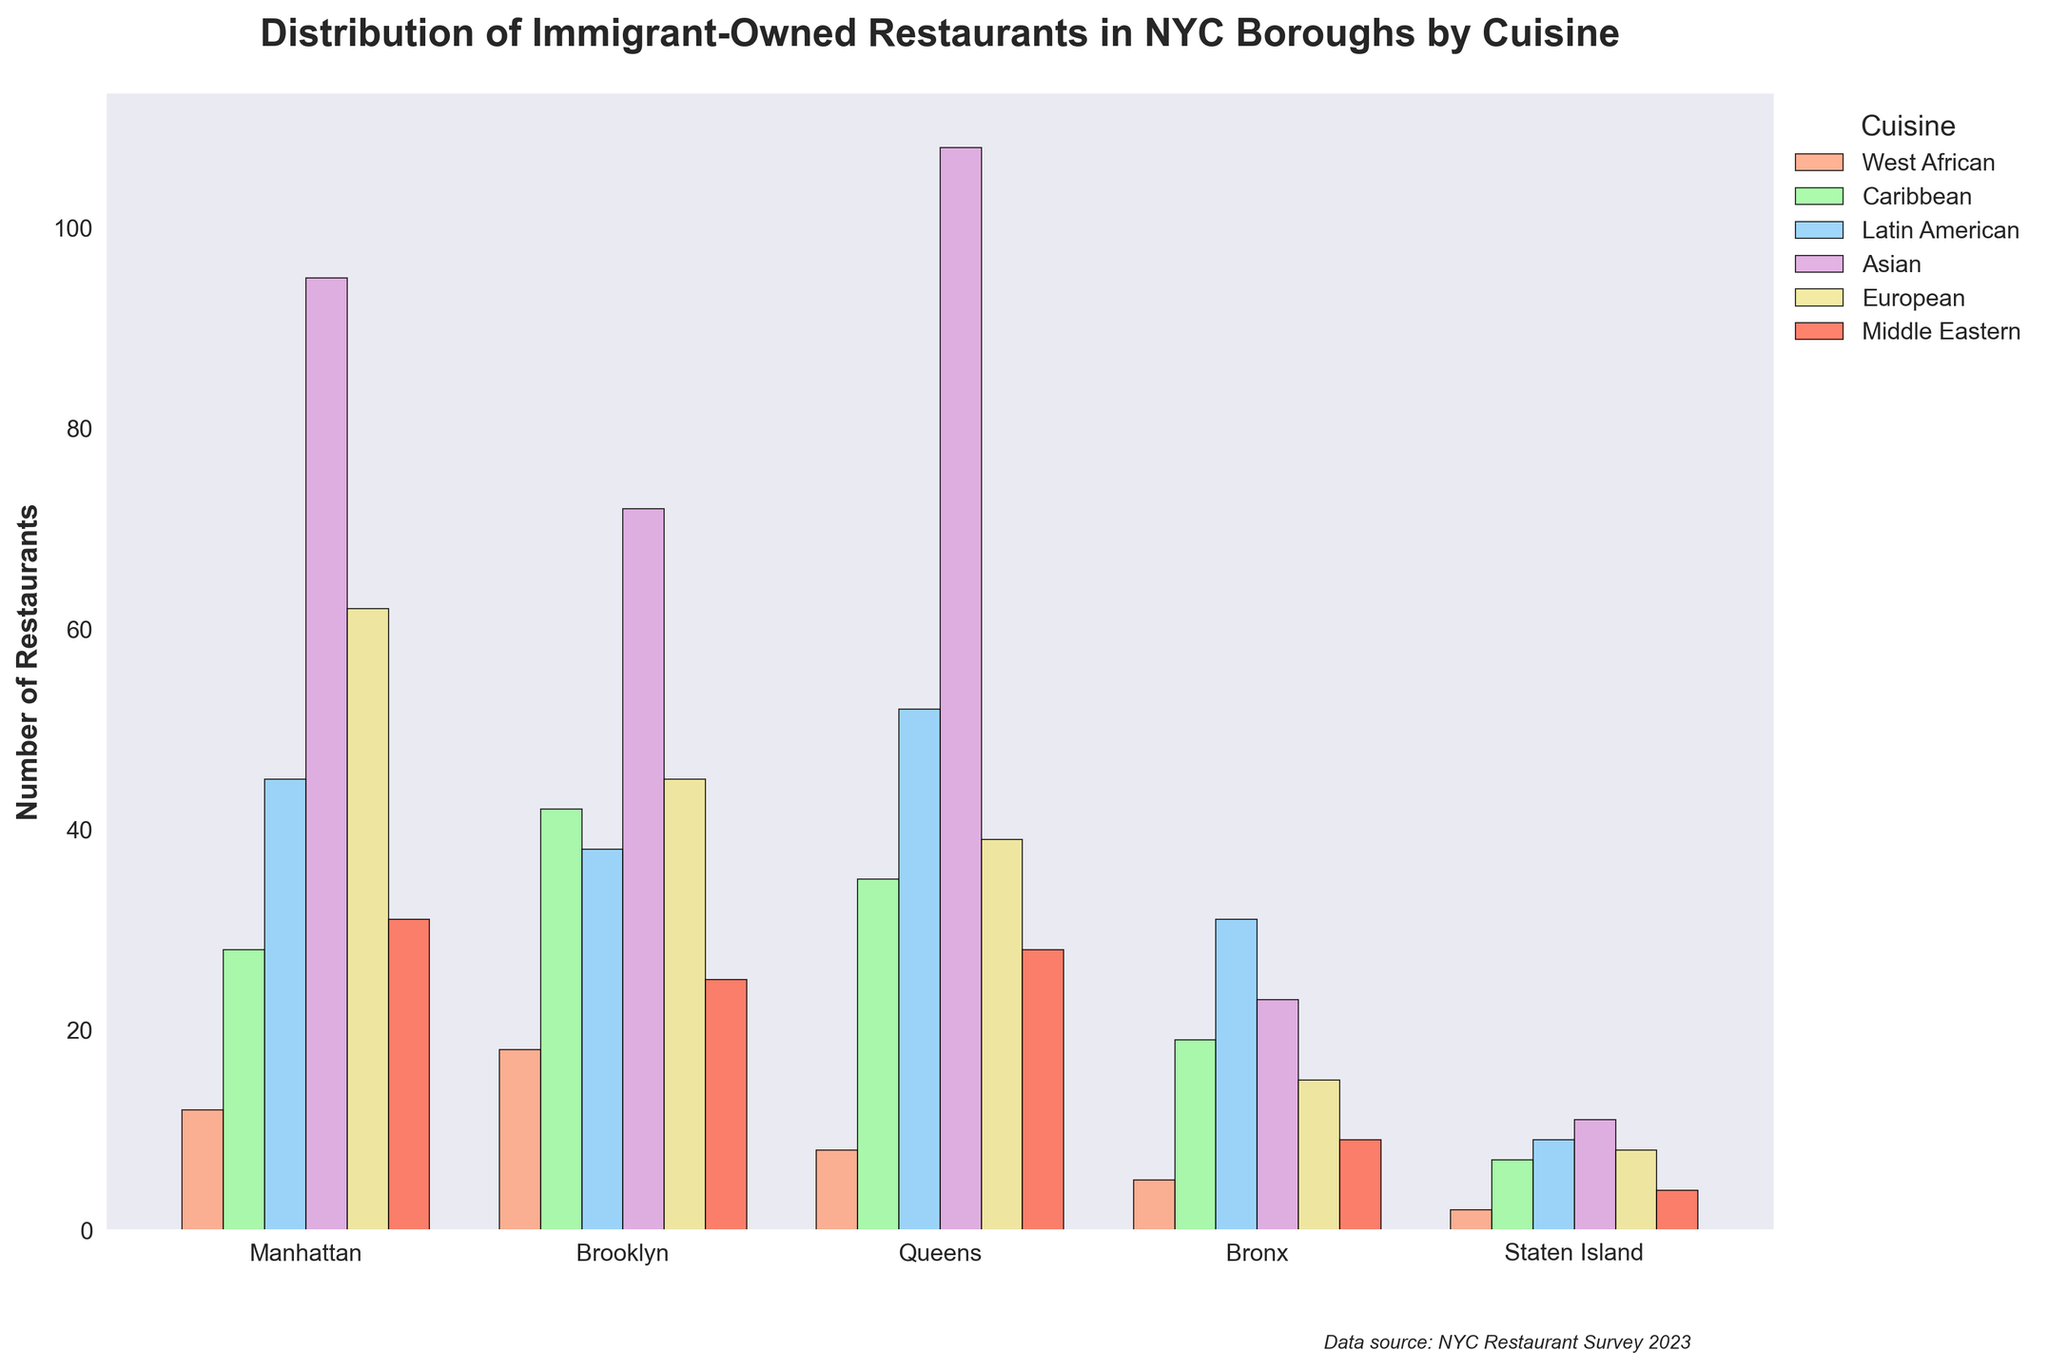What borough has the highest number of immigrant-owned Asian restaurants? The figure shows the number of immigrant-owned Asian restaurants in each borough. Looking at the Asian category, Queens has the highest number with 108 restaurants.
Answer: Queens Which cuisine is the most represented in the Bronx? By comparing the heights of the bars for each cuisine in the Bronx, Latin American stands out with the highest value of 31.
Answer: Latin American How many more Caribbean restaurants are there in Brooklyn compared to Staten Island? The number of Caribbean restaurants in Brooklyn is 42, while in Staten Island it is 7. Subtracting 7 from 42 gives us 35 more Caribbean restaurants in Brooklyn.
Answer: 35 Which borough has the smallest number of immigrant-owned European restaurants? The figure shows the number of European restaurants in each borough. Staten Island has the smallest number with 8 restaurants.
Answer: Staten Island If we sum up the number of Middle Eastern restaurants in Manhattan and Brooklyn, what do we get? Manhattan has 31 Middle Eastern restaurants, and Brooklyn has 25. Adding these together gives us 31 + 25 = 56.
Answer: 56 What is the average number of Latin American restaurants in all boroughs? Adding the number of Latin American restaurants across all boroughs: 45 (Manhattan) + 38 (Brooklyn) + 52 (Queens) + 31 (Bronx) + 9 (Staten Island) = 175. Dividing by the number of boroughs (5) gives us an average of 35.
Answer: 35 In which borough are immigrant-owned West African restaurants least represented? The figure shows the number of West African restaurants in each borough. Staten Island has the least, with only 2.
Answer: Staten Island Compare the number of West African restaurants in Manhattan to those in Brooklyn. Which borough has more? Manhattan has 12 West African restaurants, while Brooklyn has 18. Brooklyn has more West African restaurants.
Answer: Brooklyn How many more European restaurants are there in Manhattan compared to Queens? Manhattan has 62 European restaurants, and Queens has 39. Subtracting 39 from 62 gives us 23 more European restaurants in Manhattan.
Answer: 23 Which cuisine has the highest total number of restaurants across all boroughs? By summing up the numbers for each cuisine in all the boroughs, Asian cuisine has the highest total. Specifically: 95 (Manhattan) + 72 (Brooklyn) + 108 (Queens) + 23 (Bronx) + 11 (Staten Island) = 309.
Answer: Asian 